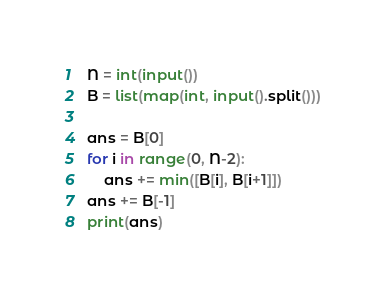<code> <loc_0><loc_0><loc_500><loc_500><_Python_>N = int(input())
B = list(map(int, input().split()))

ans = B[0]
for i in range(0, N-2):
    ans += min([B[i], B[i+1]])
ans += B[-1]
print(ans)</code> 